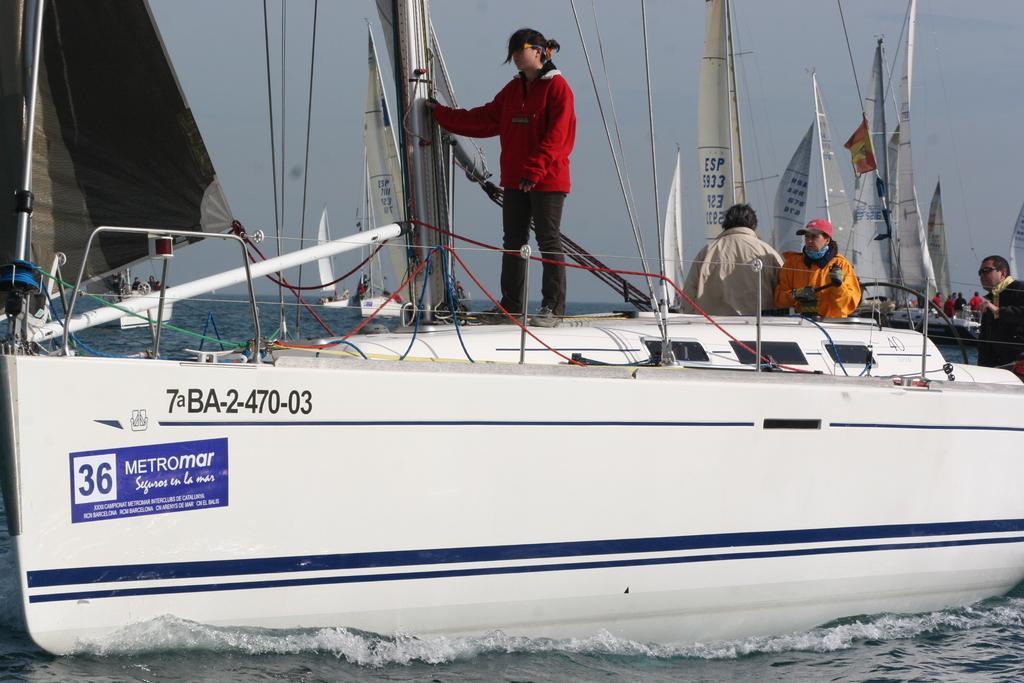How would you summarize this image in a sentence or two? In this picture we can see water at the bottom, there are some boats in the water, we can see some people standing in these boats, there are sails of the boats in the middle, we can see the sky at the top of the picture, there is some text on the boat. 